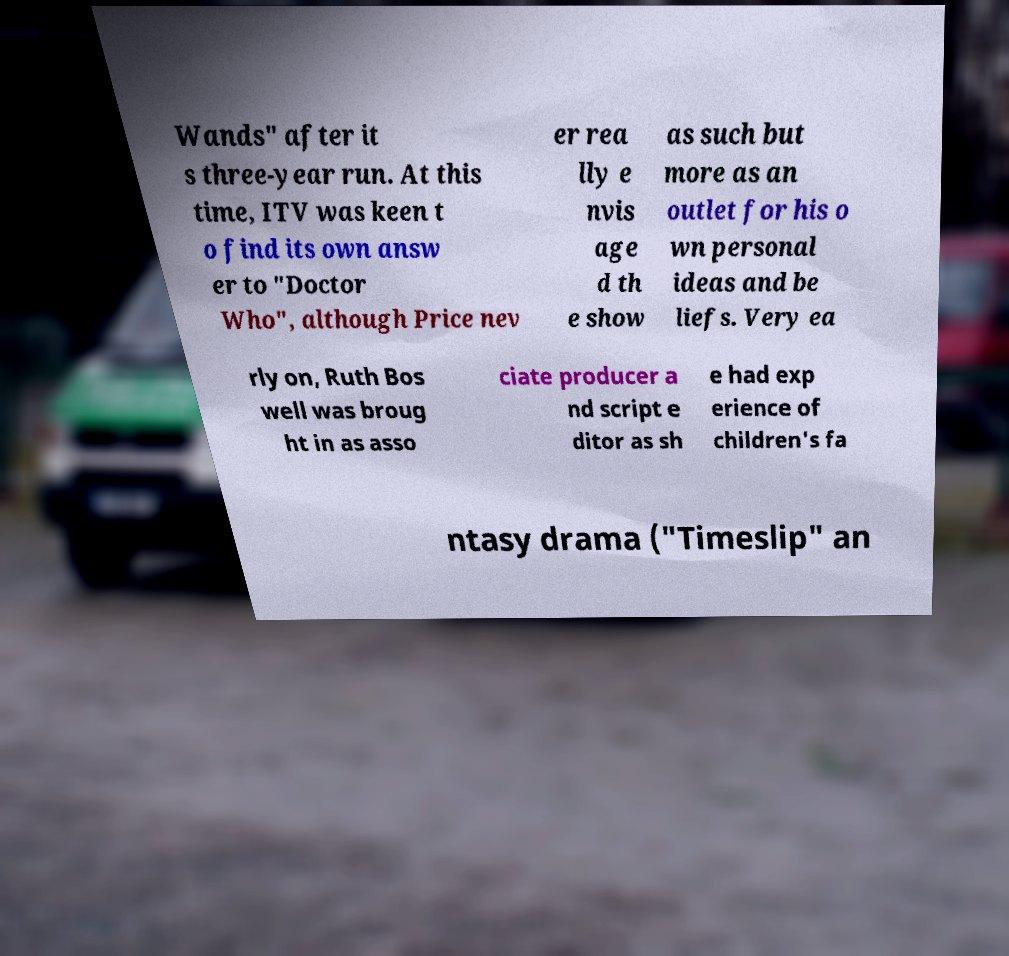What messages or text are displayed in this image? I need them in a readable, typed format. Wands" after it s three-year run. At this time, ITV was keen t o find its own answ er to "Doctor Who", although Price nev er rea lly e nvis age d th e show as such but more as an outlet for his o wn personal ideas and be liefs. Very ea rly on, Ruth Bos well was broug ht in as asso ciate producer a nd script e ditor as sh e had exp erience of children's fa ntasy drama ("Timeslip" an 